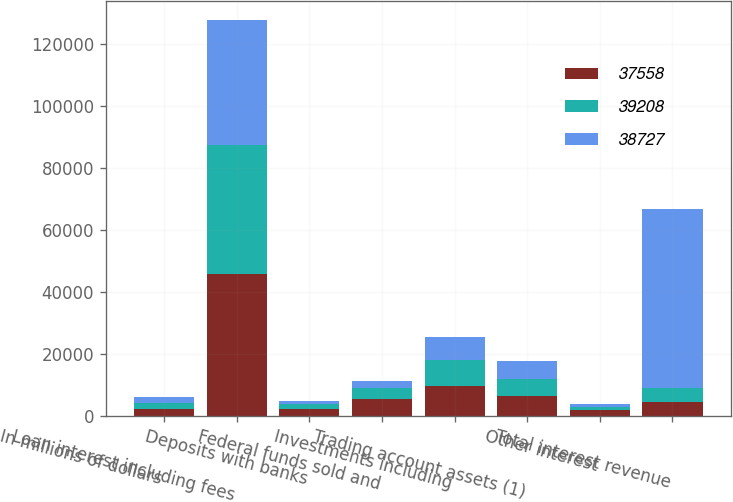Convert chart. <chart><loc_0><loc_0><loc_500><loc_500><stacked_bar_chart><ecel><fcel>In millions of dollars<fcel>Loan interest including fees<fcel>Deposits with banks<fcel>Federal funds sold and<fcel>Investments including<fcel>Trading account assets (1)<fcel>Other interest<fcel>Total interest revenue<nl><fcel>37558<fcel>2018<fcel>45682<fcel>2203<fcel>5492<fcel>9494<fcel>6284<fcel>1673<fcel>4370.5<nl><fcel>39208<fcel>2017<fcel>41736<fcel>1635<fcel>3249<fcel>8295<fcel>5501<fcel>1163<fcel>4370.5<nl><fcel>38727<fcel>2016<fcel>40125<fcel>971<fcel>2543<fcel>7582<fcel>5738<fcel>1029<fcel>57988<nl></chart> 